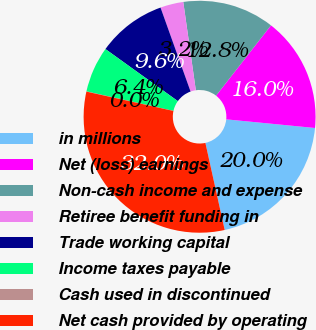<chart> <loc_0><loc_0><loc_500><loc_500><pie_chart><fcel>in millions<fcel>Net (loss) earnings<fcel>Non-cash income and expense<fcel>Retiree benefit funding in<fcel>Trade working capital<fcel>Income taxes payable<fcel>Cash used in discontinued<fcel>Net cash provided by operating<nl><fcel>19.98%<fcel>15.99%<fcel>12.8%<fcel>3.22%<fcel>9.61%<fcel>6.41%<fcel>0.03%<fcel>31.95%<nl></chart> 